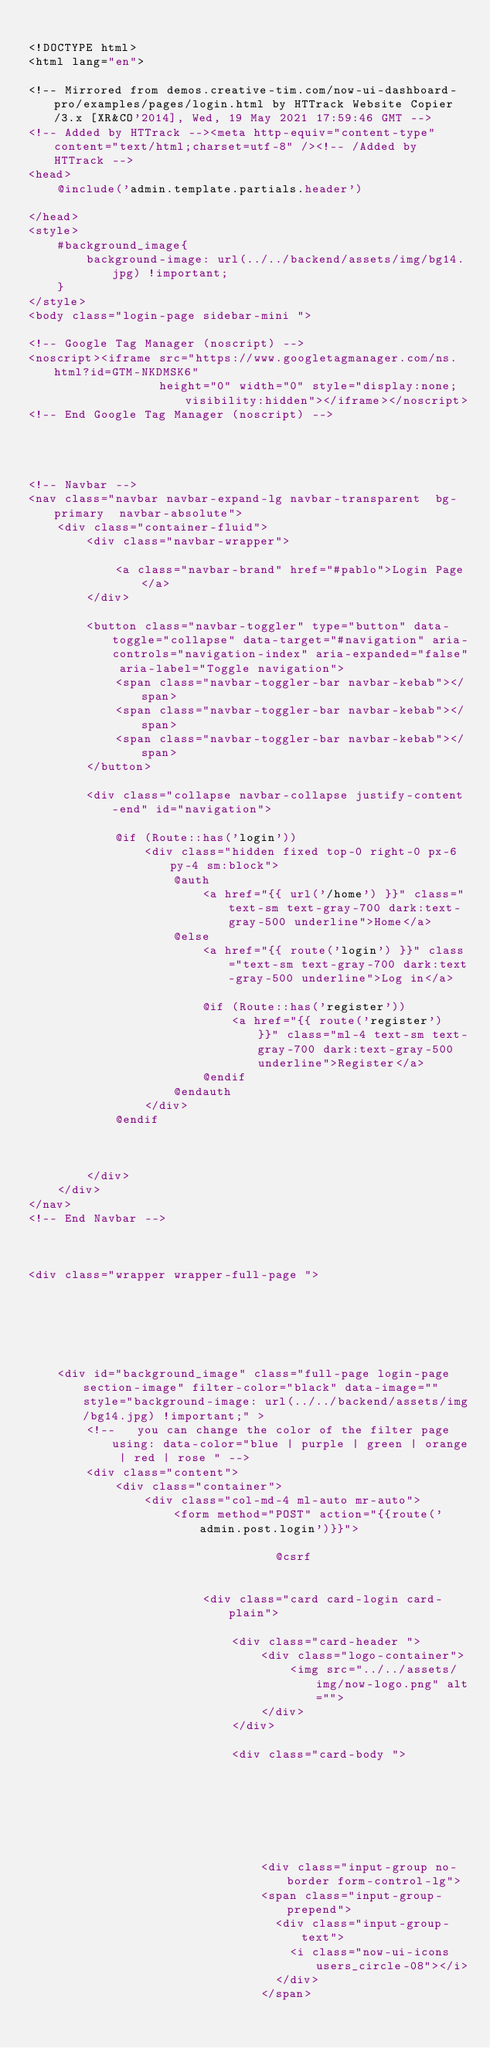Convert code to text. <code><loc_0><loc_0><loc_500><loc_500><_PHP_>
<!DOCTYPE html>
<html lang="en">

<!-- Mirrored from demos.creative-tim.com/now-ui-dashboard-pro/examples/pages/login.html by HTTrack Website Copier/3.x [XR&CO'2014], Wed, 19 May 2021 17:59:46 GMT -->
<!-- Added by HTTrack --><meta http-equiv="content-type" content="text/html;charset=utf-8" /><!-- /Added by HTTrack -->
<head>
    @include('admin.template.partials.header')

</head>
<style>
    #background_image{
        background-image: url(../../backend/assets/img/bg14.jpg) !important;
    }
</style>
<body class="login-page sidebar-mini ">

<!-- Google Tag Manager (noscript) -->
<noscript><iframe src="https://www.googletagmanager.com/ns.html?id=GTM-NKDMSK6"
                  height="0" width="0" style="display:none;visibility:hidden"></iframe></noscript>
<!-- End Google Tag Manager (noscript) -->




<!-- Navbar -->
<nav class="navbar navbar-expand-lg navbar-transparent  bg-primary  navbar-absolute">
    <div class="container-fluid">
        <div class="navbar-wrapper">

            <a class="navbar-brand" href="#pablo">Login Page</a>
        </div>

        <button class="navbar-toggler" type="button" data-toggle="collapse" data-target="#navigation" aria-controls="navigation-index" aria-expanded="false" aria-label="Toggle navigation">
            <span class="navbar-toggler-bar navbar-kebab"></span>
            <span class="navbar-toggler-bar navbar-kebab"></span>
            <span class="navbar-toggler-bar navbar-kebab"></span>
        </button>

        <div class="collapse navbar-collapse justify-content-end" id="navigation">

            @if (Route::has('login'))
                <div class="hidden fixed top-0 right-0 px-6 py-4 sm:block">
                    @auth
                        <a href="{{ url('/home') }}" class="text-sm text-gray-700 dark:text-gray-500 underline">Home</a>
                    @else
                        <a href="{{ route('login') }}" class="text-sm text-gray-700 dark:text-gray-500 underline">Log in</a>

                        @if (Route::has('register'))
                            <a href="{{ route('register') }}" class="ml-4 text-sm text-gray-700 dark:text-gray-500 underline">Register</a>
                        @endif
                    @endauth
                </div>
            @endif



        </div>
    </div>
</nav>
<!-- End Navbar -->



<div class="wrapper wrapper-full-page ">






    <div id="background_image" class="full-page login-page section-image" filter-color="black" data-image="" style="background-image: url(../../backend/assets/img/bg14.jpg) !important;" >
        <!--   you can change the color of the filter page using: data-color="blue | purple | green | orange | red | rose " -->
        <div class="content">
            <div class="container">
                <div class="col-md-4 ml-auto mr-auto">
                    <form method="POST" action="{{route('admin.post.login')}}">

                                  @csrf


                        <div class="card card-login card-plain">

                            <div class="card-header ">
                                <div class="logo-container">
                                    <img src="../../assets/img/now-logo.png" alt="">
                                </div>
                            </div>

                            <div class="card-body ">







                                <div class="input-group no-border form-control-lg">
                                <span class="input-group-prepend">
                                  <div class="input-group-text">
                                    <i class="now-ui-icons users_circle-08"></i>
                                  </div>
                                </span></code> 